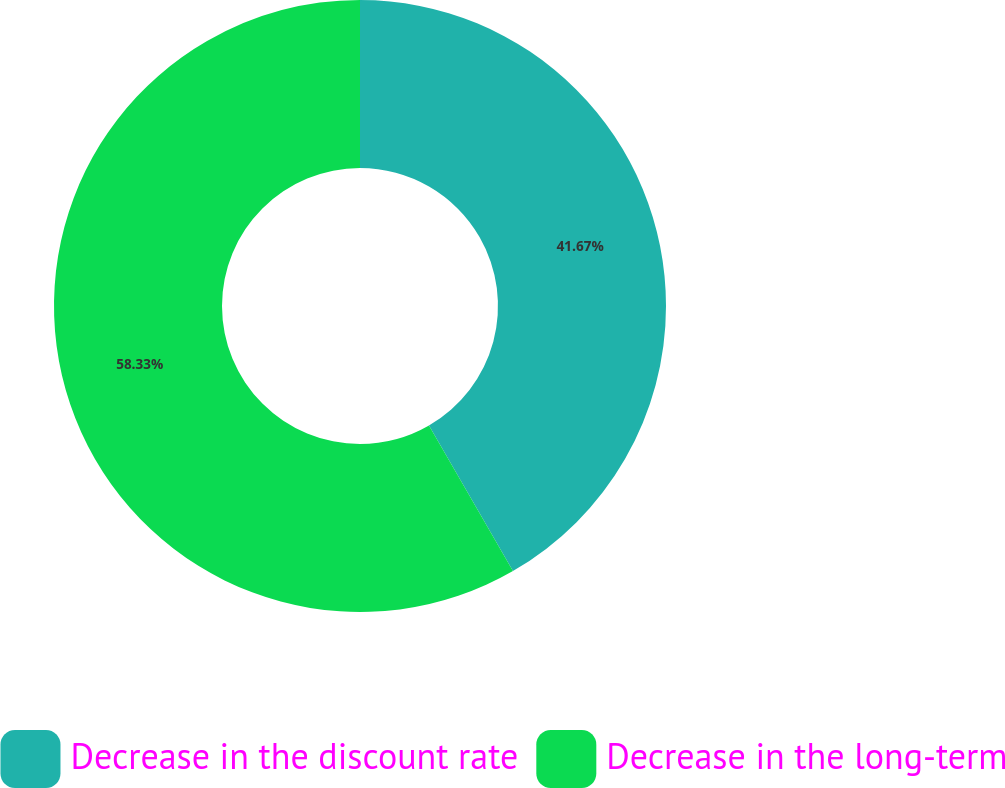Convert chart. <chart><loc_0><loc_0><loc_500><loc_500><pie_chart><fcel>Decrease in the discount rate<fcel>Decrease in the long-term<nl><fcel>41.67%<fcel>58.33%<nl></chart> 